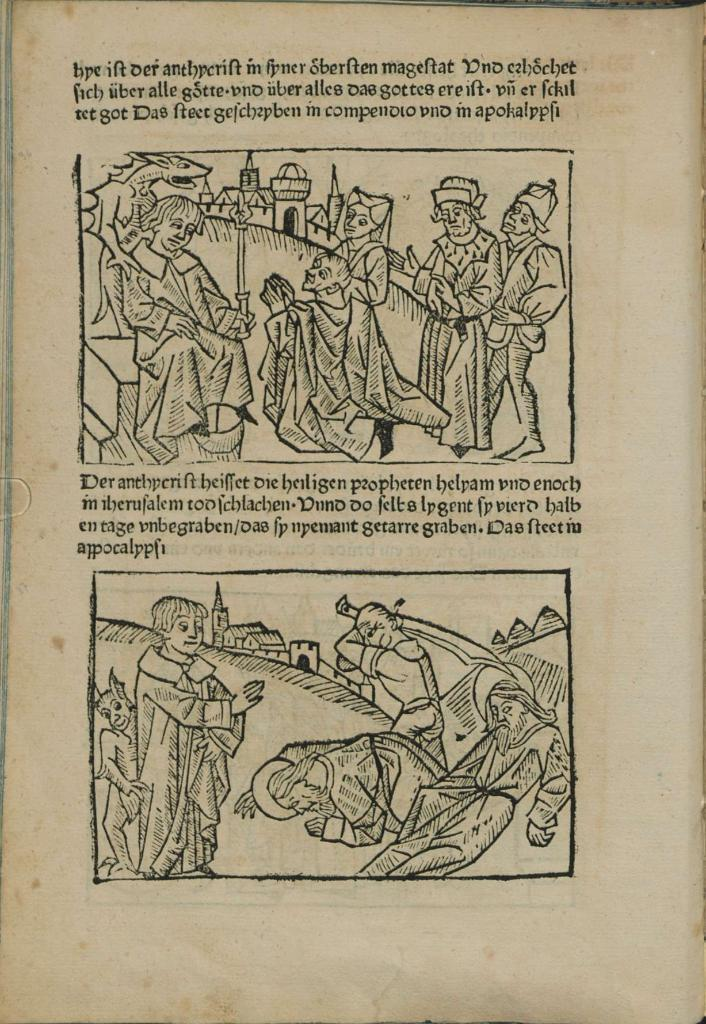What can be found in the image that contains written information? There is text in the image. What type of content is depicted on the paper in the image? There are pictures of people on a paper in the image. Where is the baby located in the image? There is no baby present in the image. What type of board is used to display the pictures of people in the image? The provided facts do not mention a board; the pictures of people are on a paper. 